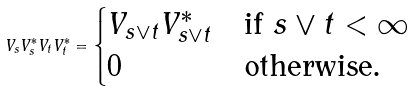Convert formula to latex. <formula><loc_0><loc_0><loc_500><loc_500>V _ { s } V _ { s } ^ { * } V _ { t } V _ { t } ^ { * } = \begin{cases} V _ { s \vee t } V _ { s \vee t } ^ { * } & \text {if $s\vee t < \infty$} \\ 0 & \text {otherwise.} \end{cases}</formula> 